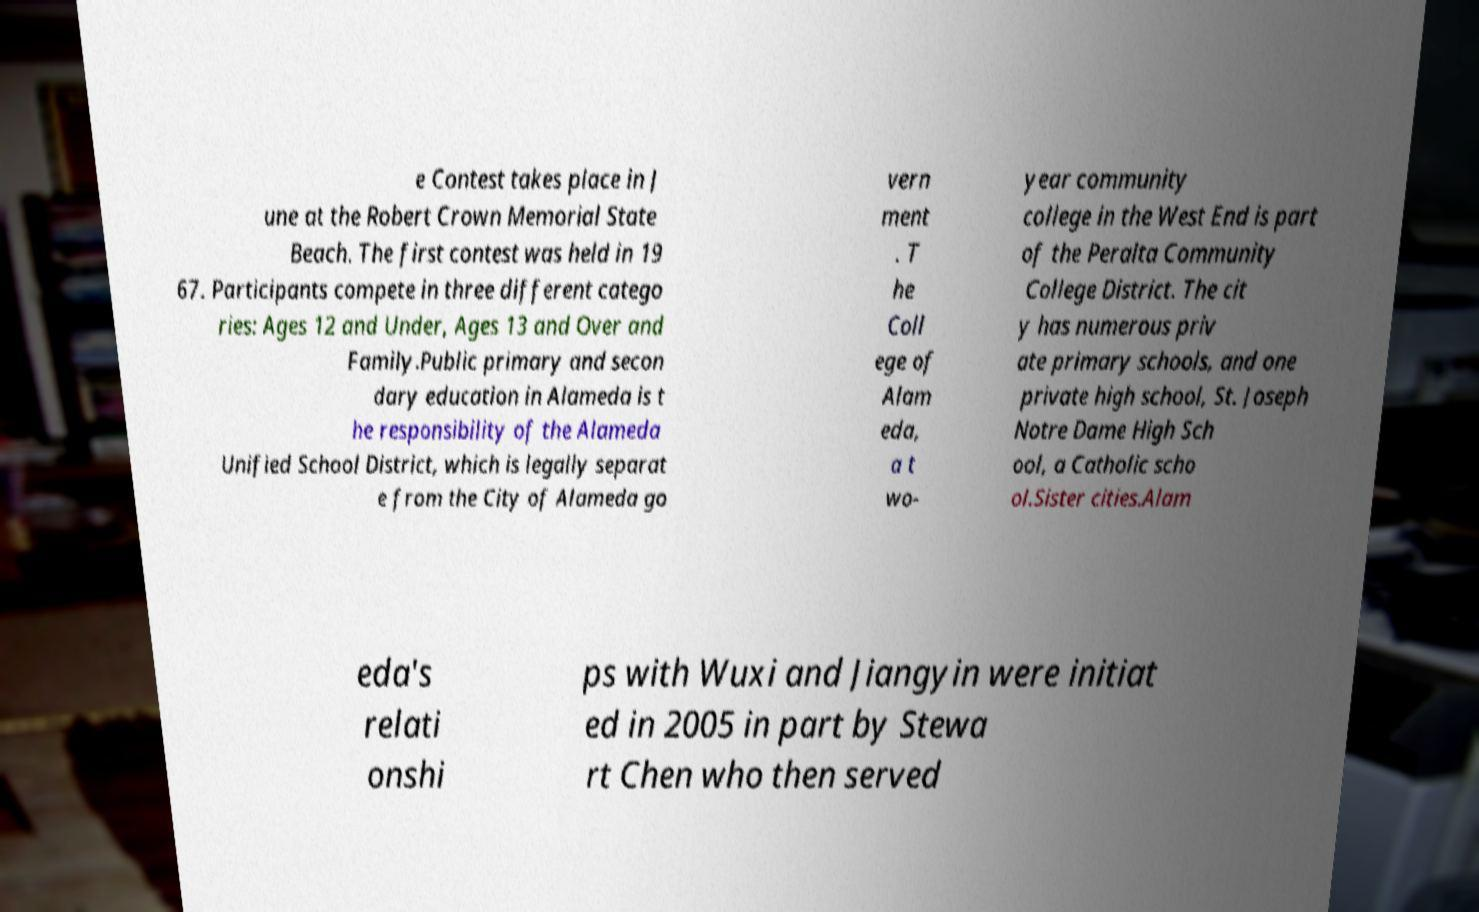Could you assist in decoding the text presented in this image and type it out clearly? e Contest takes place in J une at the Robert Crown Memorial State Beach. The first contest was held in 19 67. Participants compete in three different catego ries: Ages 12 and Under, Ages 13 and Over and Family.Public primary and secon dary education in Alameda is t he responsibility of the Alameda Unified School District, which is legally separat e from the City of Alameda go vern ment . T he Coll ege of Alam eda, a t wo- year community college in the West End is part of the Peralta Community College District. The cit y has numerous priv ate primary schools, and one private high school, St. Joseph Notre Dame High Sch ool, a Catholic scho ol.Sister cities.Alam eda's relati onshi ps with Wuxi and Jiangyin were initiat ed in 2005 in part by Stewa rt Chen who then served 